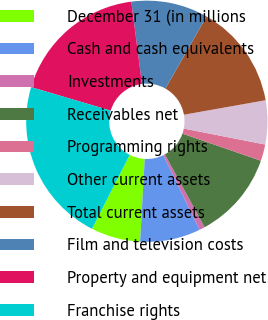Convert chart. <chart><loc_0><loc_0><loc_500><loc_500><pie_chart><fcel>December 31 (in millions<fcel>Cash and cash equivalents<fcel>Investments<fcel>Receivables net<fcel>Programming rights<fcel>Other current assets<fcel>Total current assets<fcel>Film and television costs<fcel>Property and equipment net<fcel>Franchise rights<nl><fcel>6.62%<fcel>8.09%<fcel>0.74%<fcel>11.76%<fcel>2.21%<fcel>5.88%<fcel>13.97%<fcel>10.29%<fcel>18.38%<fcel>22.06%<nl></chart> 